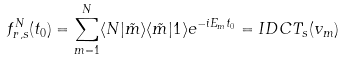Convert formula to latex. <formula><loc_0><loc_0><loc_500><loc_500>f ^ { N } _ { r , s } ( t _ { 0 } ) = \sum _ { m = 1 } ^ { N } \langle { N } | \tilde { m } \rangle \langle \tilde { m } | { 1 } \rangle e ^ { - i E _ { m } t _ { 0 } } = I D C T _ { s } ( v _ { m } )</formula> 